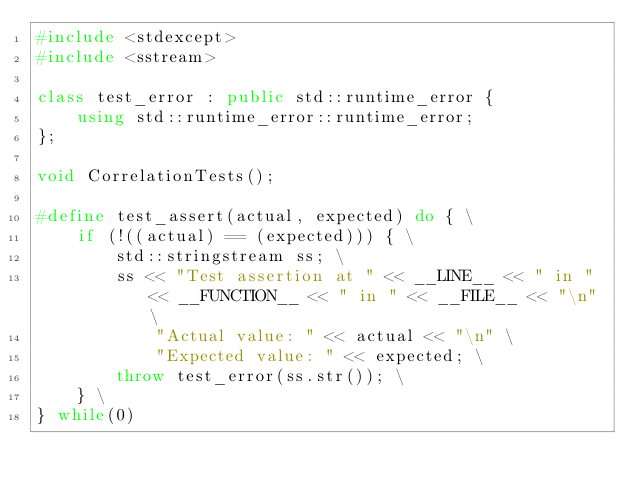Convert code to text. <code><loc_0><loc_0><loc_500><loc_500><_C++_>#include <stdexcept>
#include <sstream>

class test_error : public std::runtime_error {
	using std::runtime_error::runtime_error;
};

void CorrelationTests();

#define test_assert(actual, expected) do { \
	if (!((actual) == (expected))) { \
		std::stringstream ss; \
		ss << "Test assertion at " << __LINE__ << " in " << __FUNCTION__ << " in " << __FILE__ << "\n" \
			"Actual value: " << actual << "\n" \
			"Expected value: " << expected; \
		throw test_error(ss.str()); \
	} \
} while(0)
</code> 